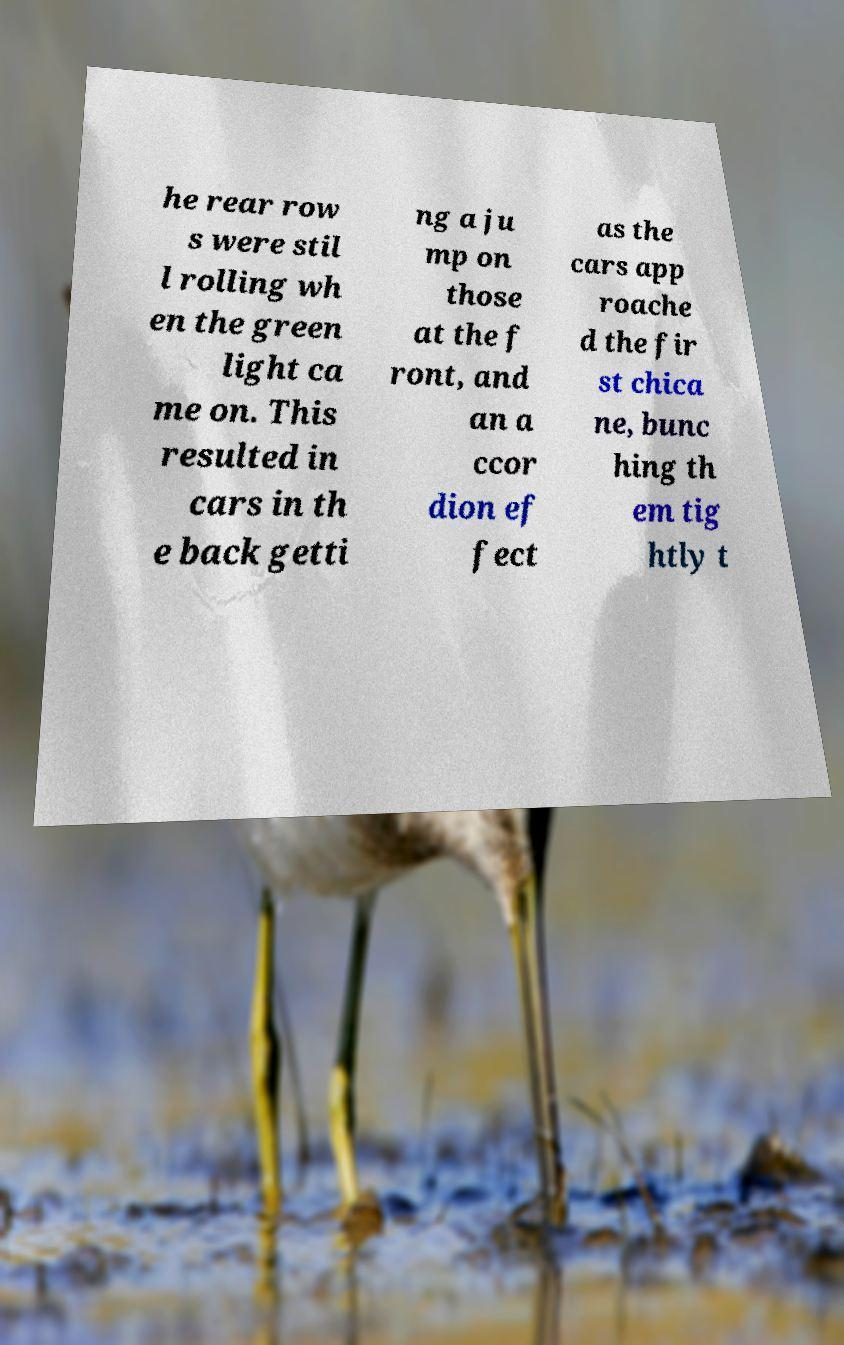Can you accurately transcribe the text from the provided image for me? he rear row s were stil l rolling wh en the green light ca me on. This resulted in cars in th e back getti ng a ju mp on those at the f ront, and an a ccor dion ef fect as the cars app roache d the fir st chica ne, bunc hing th em tig htly t 